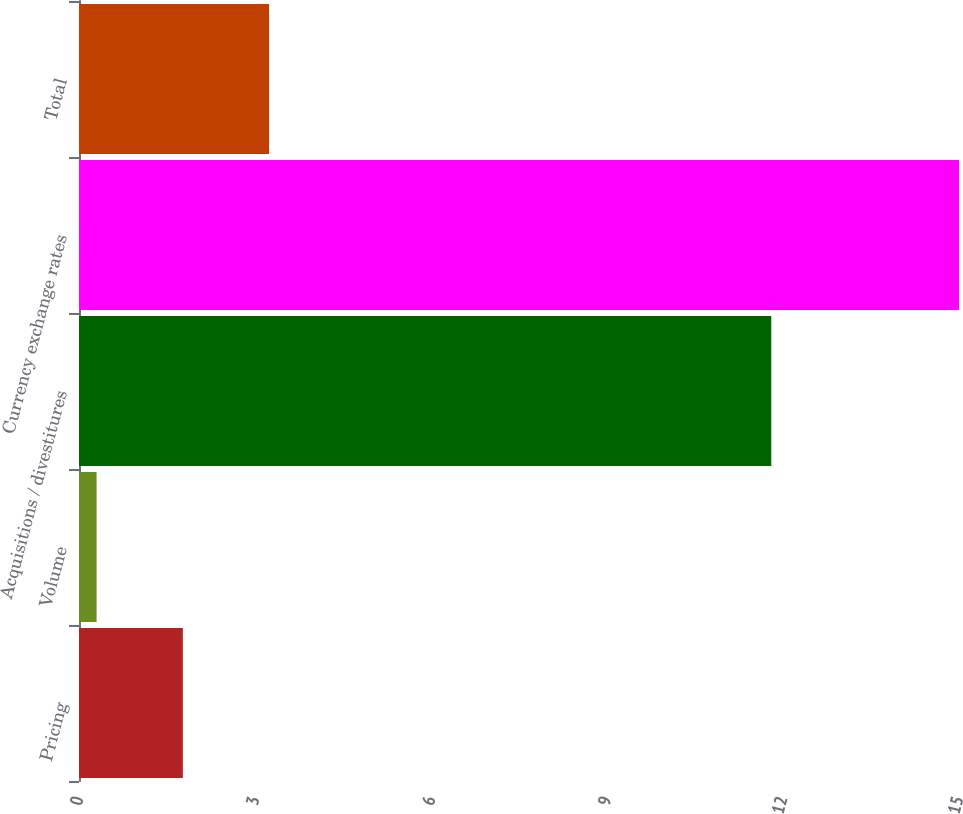Convert chart to OTSL. <chart><loc_0><loc_0><loc_500><loc_500><bar_chart><fcel>Pricing<fcel>Volume<fcel>Acquisitions / divestitures<fcel>Currency exchange rates<fcel>Total<nl><fcel>1.77<fcel>0.3<fcel>11.8<fcel>15<fcel>3.24<nl></chart> 